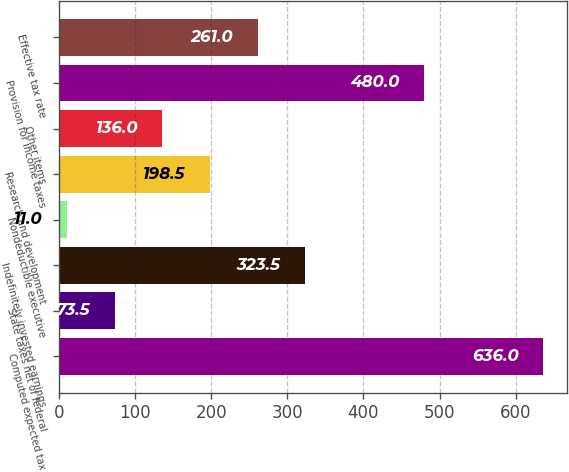Convert chart. <chart><loc_0><loc_0><loc_500><loc_500><bar_chart><fcel>Computed expected tax<fcel>State taxes net of federal<fcel>Indefinitely invested earnings<fcel>Nondeductible executive<fcel>Research and development<fcel>Other items<fcel>Provision for income taxes<fcel>Effective tax rate<nl><fcel>636<fcel>73.5<fcel>323.5<fcel>11<fcel>198.5<fcel>136<fcel>480<fcel>261<nl></chart> 